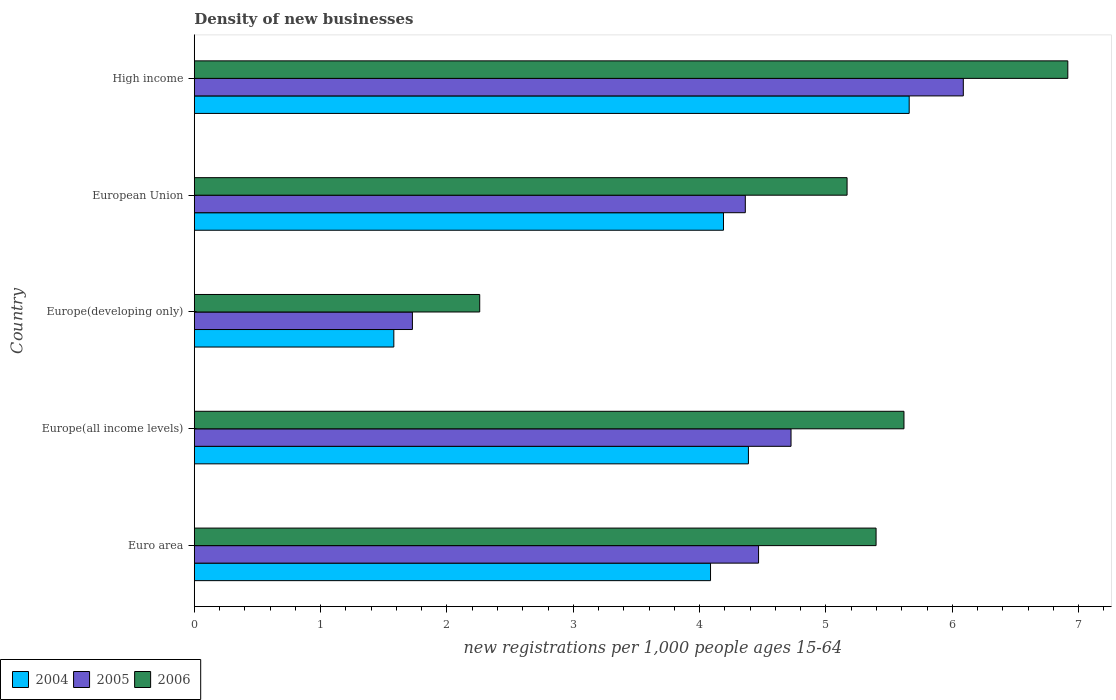How many different coloured bars are there?
Your response must be concise. 3. Are the number of bars per tick equal to the number of legend labels?
Give a very brief answer. Yes. Are the number of bars on each tick of the Y-axis equal?
Make the answer very short. Yes. How many bars are there on the 5th tick from the bottom?
Your response must be concise. 3. What is the label of the 5th group of bars from the top?
Your response must be concise. Euro area. What is the number of new registrations in 2004 in Europe(all income levels)?
Offer a terse response. 4.39. Across all countries, what is the maximum number of new registrations in 2005?
Give a very brief answer. 6.09. Across all countries, what is the minimum number of new registrations in 2004?
Make the answer very short. 1.58. In which country was the number of new registrations in 2005 minimum?
Your response must be concise. Europe(developing only). What is the total number of new registrations in 2004 in the graph?
Make the answer very short. 19.9. What is the difference between the number of new registrations in 2005 in European Union and that in High income?
Ensure brevity in your answer.  -1.73. What is the difference between the number of new registrations in 2004 in Euro area and the number of new registrations in 2006 in European Union?
Offer a very short reply. -1.08. What is the average number of new registrations in 2005 per country?
Offer a very short reply. 4.27. What is the difference between the number of new registrations in 2006 and number of new registrations in 2004 in High income?
Give a very brief answer. 1.26. In how many countries, is the number of new registrations in 2004 greater than 5.6 ?
Keep it short and to the point. 1. What is the ratio of the number of new registrations in 2004 in Euro area to that in Europe(developing only)?
Ensure brevity in your answer.  2.59. Is the number of new registrations in 2004 in Europe(all income levels) less than that in High income?
Offer a terse response. Yes. Is the difference between the number of new registrations in 2006 in Europe(developing only) and High income greater than the difference between the number of new registrations in 2004 in Europe(developing only) and High income?
Offer a terse response. No. What is the difference between the highest and the second highest number of new registrations in 2005?
Ensure brevity in your answer.  1.36. What is the difference between the highest and the lowest number of new registrations in 2005?
Provide a short and direct response. 4.36. What does the 3rd bar from the top in Euro area represents?
Offer a terse response. 2004. Is it the case that in every country, the sum of the number of new registrations in 2004 and number of new registrations in 2006 is greater than the number of new registrations in 2005?
Ensure brevity in your answer.  Yes. What is the difference between two consecutive major ticks on the X-axis?
Make the answer very short. 1. Where does the legend appear in the graph?
Give a very brief answer. Bottom left. What is the title of the graph?
Provide a succinct answer. Density of new businesses. Does "1962" appear as one of the legend labels in the graph?
Provide a short and direct response. No. What is the label or title of the X-axis?
Your answer should be compact. New registrations per 1,0 people ages 15-64. What is the new registrations per 1,000 people ages 15-64 in 2004 in Euro area?
Make the answer very short. 4.09. What is the new registrations per 1,000 people ages 15-64 of 2005 in Euro area?
Make the answer very short. 4.47. What is the new registrations per 1,000 people ages 15-64 of 2006 in Euro area?
Offer a very short reply. 5.4. What is the new registrations per 1,000 people ages 15-64 of 2004 in Europe(all income levels)?
Ensure brevity in your answer.  4.39. What is the new registrations per 1,000 people ages 15-64 in 2005 in Europe(all income levels)?
Give a very brief answer. 4.72. What is the new registrations per 1,000 people ages 15-64 of 2006 in Europe(all income levels)?
Your answer should be compact. 5.62. What is the new registrations per 1,000 people ages 15-64 in 2004 in Europe(developing only)?
Your response must be concise. 1.58. What is the new registrations per 1,000 people ages 15-64 of 2005 in Europe(developing only)?
Your response must be concise. 1.73. What is the new registrations per 1,000 people ages 15-64 in 2006 in Europe(developing only)?
Provide a succinct answer. 2.26. What is the new registrations per 1,000 people ages 15-64 of 2004 in European Union?
Your answer should be compact. 4.19. What is the new registrations per 1,000 people ages 15-64 of 2005 in European Union?
Provide a short and direct response. 4.36. What is the new registrations per 1,000 people ages 15-64 in 2006 in European Union?
Your answer should be compact. 5.17. What is the new registrations per 1,000 people ages 15-64 of 2004 in High income?
Make the answer very short. 5.66. What is the new registrations per 1,000 people ages 15-64 of 2005 in High income?
Your response must be concise. 6.09. What is the new registrations per 1,000 people ages 15-64 of 2006 in High income?
Your answer should be very brief. 6.91. Across all countries, what is the maximum new registrations per 1,000 people ages 15-64 of 2004?
Offer a very short reply. 5.66. Across all countries, what is the maximum new registrations per 1,000 people ages 15-64 in 2005?
Your answer should be very brief. 6.09. Across all countries, what is the maximum new registrations per 1,000 people ages 15-64 in 2006?
Give a very brief answer. 6.91. Across all countries, what is the minimum new registrations per 1,000 people ages 15-64 of 2004?
Make the answer very short. 1.58. Across all countries, what is the minimum new registrations per 1,000 people ages 15-64 in 2005?
Your answer should be compact. 1.73. Across all countries, what is the minimum new registrations per 1,000 people ages 15-64 of 2006?
Offer a terse response. 2.26. What is the total new registrations per 1,000 people ages 15-64 in 2004 in the graph?
Your response must be concise. 19.9. What is the total new registrations per 1,000 people ages 15-64 in 2005 in the graph?
Offer a very short reply. 21.37. What is the total new registrations per 1,000 people ages 15-64 in 2006 in the graph?
Ensure brevity in your answer.  25.36. What is the difference between the new registrations per 1,000 people ages 15-64 in 2004 in Euro area and that in Europe(all income levels)?
Offer a very short reply. -0.3. What is the difference between the new registrations per 1,000 people ages 15-64 in 2005 in Euro area and that in Europe(all income levels)?
Make the answer very short. -0.26. What is the difference between the new registrations per 1,000 people ages 15-64 in 2006 in Euro area and that in Europe(all income levels)?
Give a very brief answer. -0.22. What is the difference between the new registrations per 1,000 people ages 15-64 in 2004 in Euro area and that in Europe(developing only)?
Provide a short and direct response. 2.51. What is the difference between the new registrations per 1,000 people ages 15-64 in 2005 in Euro area and that in Europe(developing only)?
Your answer should be very brief. 2.74. What is the difference between the new registrations per 1,000 people ages 15-64 of 2006 in Euro area and that in Europe(developing only)?
Make the answer very short. 3.14. What is the difference between the new registrations per 1,000 people ages 15-64 of 2004 in Euro area and that in European Union?
Provide a succinct answer. -0.1. What is the difference between the new registrations per 1,000 people ages 15-64 of 2005 in Euro area and that in European Union?
Make the answer very short. 0.1. What is the difference between the new registrations per 1,000 people ages 15-64 of 2006 in Euro area and that in European Union?
Your answer should be compact. 0.23. What is the difference between the new registrations per 1,000 people ages 15-64 in 2004 in Euro area and that in High income?
Offer a very short reply. -1.57. What is the difference between the new registrations per 1,000 people ages 15-64 of 2005 in Euro area and that in High income?
Keep it short and to the point. -1.62. What is the difference between the new registrations per 1,000 people ages 15-64 in 2006 in Euro area and that in High income?
Provide a short and direct response. -1.52. What is the difference between the new registrations per 1,000 people ages 15-64 in 2004 in Europe(all income levels) and that in Europe(developing only)?
Give a very brief answer. 2.81. What is the difference between the new registrations per 1,000 people ages 15-64 of 2005 in Europe(all income levels) and that in Europe(developing only)?
Your answer should be compact. 3. What is the difference between the new registrations per 1,000 people ages 15-64 of 2006 in Europe(all income levels) and that in Europe(developing only)?
Give a very brief answer. 3.36. What is the difference between the new registrations per 1,000 people ages 15-64 of 2004 in Europe(all income levels) and that in European Union?
Your response must be concise. 0.2. What is the difference between the new registrations per 1,000 people ages 15-64 of 2005 in Europe(all income levels) and that in European Union?
Your answer should be compact. 0.36. What is the difference between the new registrations per 1,000 people ages 15-64 of 2006 in Europe(all income levels) and that in European Union?
Provide a short and direct response. 0.45. What is the difference between the new registrations per 1,000 people ages 15-64 in 2004 in Europe(all income levels) and that in High income?
Make the answer very short. -1.27. What is the difference between the new registrations per 1,000 people ages 15-64 of 2005 in Europe(all income levels) and that in High income?
Your answer should be compact. -1.36. What is the difference between the new registrations per 1,000 people ages 15-64 in 2006 in Europe(all income levels) and that in High income?
Make the answer very short. -1.3. What is the difference between the new registrations per 1,000 people ages 15-64 of 2004 in Europe(developing only) and that in European Union?
Keep it short and to the point. -2.61. What is the difference between the new registrations per 1,000 people ages 15-64 in 2005 in Europe(developing only) and that in European Union?
Ensure brevity in your answer.  -2.64. What is the difference between the new registrations per 1,000 people ages 15-64 in 2006 in Europe(developing only) and that in European Union?
Keep it short and to the point. -2.91. What is the difference between the new registrations per 1,000 people ages 15-64 of 2004 in Europe(developing only) and that in High income?
Provide a short and direct response. -4.08. What is the difference between the new registrations per 1,000 people ages 15-64 of 2005 in Europe(developing only) and that in High income?
Your answer should be compact. -4.36. What is the difference between the new registrations per 1,000 people ages 15-64 of 2006 in Europe(developing only) and that in High income?
Offer a very short reply. -4.66. What is the difference between the new registrations per 1,000 people ages 15-64 of 2004 in European Union and that in High income?
Make the answer very short. -1.47. What is the difference between the new registrations per 1,000 people ages 15-64 in 2005 in European Union and that in High income?
Ensure brevity in your answer.  -1.73. What is the difference between the new registrations per 1,000 people ages 15-64 of 2006 in European Union and that in High income?
Provide a succinct answer. -1.75. What is the difference between the new registrations per 1,000 people ages 15-64 in 2004 in Euro area and the new registrations per 1,000 people ages 15-64 in 2005 in Europe(all income levels)?
Make the answer very short. -0.64. What is the difference between the new registrations per 1,000 people ages 15-64 of 2004 in Euro area and the new registrations per 1,000 people ages 15-64 of 2006 in Europe(all income levels)?
Give a very brief answer. -1.53. What is the difference between the new registrations per 1,000 people ages 15-64 in 2005 in Euro area and the new registrations per 1,000 people ages 15-64 in 2006 in Europe(all income levels)?
Provide a short and direct response. -1.15. What is the difference between the new registrations per 1,000 people ages 15-64 in 2004 in Euro area and the new registrations per 1,000 people ages 15-64 in 2005 in Europe(developing only)?
Keep it short and to the point. 2.36. What is the difference between the new registrations per 1,000 people ages 15-64 in 2004 in Euro area and the new registrations per 1,000 people ages 15-64 in 2006 in Europe(developing only)?
Keep it short and to the point. 1.83. What is the difference between the new registrations per 1,000 people ages 15-64 in 2005 in Euro area and the new registrations per 1,000 people ages 15-64 in 2006 in Europe(developing only)?
Keep it short and to the point. 2.21. What is the difference between the new registrations per 1,000 people ages 15-64 of 2004 in Euro area and the new registrations per 1,000 people ages 15-64 of 2005 in European Union?
Make the answer very short. -0.28. What is the difference between the new registrations per 1,000 people ages 15-64 in 2004 in Euro area and the new registrations per 1,000 people ages 15-64 in 2006 in European Union?
Your answer should be very brief. -1.08. What is the difference between the new registrations per 1,000 people ages 15-64 of 2005 in Euro area and the new registrations per 1,000 people ages 15-64 of 2006 in European Union?
Your answer should be very brief. -0.7. What is the difference between the new registrations per 1,000 people ages 15-64 of 2004 in Euro area and the new registrations per 1,000 people ages 15-64 of 2005 in High income?
Your answer should be compact. -2. What is the difference between the new registrations per 1,000 people ages 15-64 of 2004 in Euro area and the new registrations per 1,000 people ages 15-64 of 2006 in High income?
Offer a terse response. -2.83. What is the difference between the new registrations per 1,000 people ages 15-64 in 2005 in Euro area and the new registrations per 1,000 people ages 15-64 in 2006 in High income?
Offer a terse response. -2.45. What is the difference between the new registrations per 1,000 people ages 15-64 of 2004 in Europe(all income levels) and the new registrations per 1,000 people ages 15-64 of 2005 in Europe(developing only)?
Your answer should be very brief. 2.66. What is the difference between the new registrations per 1,000 people ages 15-64 of 2004 in Europe(all income levels) and the new registrations per 1,000 people ages 15-64 of 2006 in Europe(developing only)?
Give a very brief answer. 2.13. What is the difference between the new registrations per 1,000 people ages 15-64 of 2005 in Europe(all income levels) and the new registrations per 1,000 people ages 15-64 of 2006 in Europe(developing only)?
Provide a short and direct response. 2.46. What is the difference between the new registrations per 1,000 people ages 15-64 in 2004 in Europe(all income levels) and the new registrations per 1,000 people ages 15-64 in 2005 in European Union?
Provide a short and direct response. 0.02. What is the difference between the new registrations per 1,000 people ages 15-64 of 2004 in Europe(all income levels) and the new registrations per 1,000 people ages 15-64 of 2006 in European Union?
Your answer should be compact. -0.78. What is the difference between the new registrations per 1,000 people ages 15-64 in 2005 in Europe(all income levels) and the new registrations per 1,000 people ages 15-64 in 2006 in European Union?
Your answer should be compact. -0.44. What is the difference between the new registrations per 1,000 people ages 15-64 in 2004 in Europe(all income levels) and the new registrations per 1,000 people ages 15-64 in 2005 in High income?
Provide a succinct answer. -1.7. What is the difference between the new registrations per 1,000 people ages 15-64 in 2004 in Europe(all income levels) and the new registrations per 1,000 people ages 15-64 in 2006 in High income?
Your answer should be very brief. -2.53. What is the difference between the new registrations per 1,000 people ages 15-64 of 2005 in Europe(all income levels) and the new registrations per 1,000 people ages 15-64 of 2006 in High income?
Offer a very short reply. -2.19. What is the difference between the new registrations per 1,000 people ages 15-64 of 2004 in Europe(developing only) and the new registrations per 1,000 people ages 15-64 of 2005 in European Union?
Provide a succinct answer. -2.78. What is the difference between the new registrations per 1,000 people ages 15-64 of 2004 in Europe(developing only) and the new registrations per 1,000 people ages 15-64 of 2006 in European Union?
Provide a succinct answer. -3.59. What is the difference between the new registrations per 1,000 people ages 15-64 of 2005 in Europe(developing only) and the new registrations per 1,000 people ages 15-64 of 2006 in European Union?
Ensure brevity in your answer.  -3.44. What is the difference between the new registrations per 1,000 people ages 15-64 of 2004 in Europe(developing only) and the new registrations per 1,000 people ages 15-64 of 2005 in High income?
Offer a very short reply. -4.51. What is the difference between the new registrations per 1,000 people ages 15-64 in 2004 in Europe(developing only) and the new registrations per 1,000 people ages 15-64 in 2006 in High income?
Offer a very short reply. -5.33. What is the difference between the new registrations per 1,000 people ages 15-64 in 2005 in Europe(developing only) and the new registrations per 1,000 people ages 15-64 in 2006 in High income?
Your response must be concise. -5.19. What is the difference between the new registrations per 1,000 people ages 15-64 of 2004 in European Union and the new registrations per 1,000 people ages 15-64 of 2005 in High income?
Provide a short and direct response. -1.9. What is the difference between the new registrations per 1,000 people ages 15-64 of 2004 in European Union and the new registrations per 1,000 people ages 15-64 of 2006 in High income?
Ensure brevity in your answer.  -2.73. What is the difference between the new registrations per 1,000 people ages 15-64 of 2005 in European Union and the new registrations per 1,000 people ages 15-64 of 2006 in High income?
Give a very brief answer. -2.55. What is the average new registrations per 1,000 people ages 15-64 in 2004 per country?
Provide a succinct answer. 3.98. What is the average new registrations per 1,000 people ages 15-64 in 2005 per country?
Provide a short and direct response. 4.27. What is the average new registrations per 1,000 people ages 15-64 in 2006 per country?
Provide a short and direct response. 5.07. What is the difference between the new registrations per 1,000 people ages 15-64 in 2004 and new registrations per 1,000 people ages 15-64 in 2005 in Euro area?
Your answer should be compact. -0.38. What is the difference between the new registrations per 1,000 people ages 15-64 of 2004 and new registrations per 1,000 people ages 15-64 of 2006 in Euro area?
Your answer should be compact. -1.31. What is the difference between the new registrations per 1,000 people ages 15-64 in 2005 and new registrations per 1,000 people ages 15-64 in 2006 in Euro area?
Give a very brief answer. -0.93. What is the difference between the new registrations per 1,000 people ages 15-64 of 2004 and new registrations per 1,000 people ages 15-64 of 2005 in Europe(all income levels)?
Offer a terse response. -0.34. What is the difference between the new registrations per 1,000 people ages 15-64 of 2004 and new registrations per 1,000 people ages 15-64 of 2006 in Europe(all income levels)?
Keep it short and to the point. -1.23. What is the difference between the new registrations per 1,000 people ages 15-64 in 2005 and new registrations per 1,000 people ages 15-64 in 2006 in Europe(all income levels)?
Keep it short and to the point. -0.89. What is the difference between the new registrations per 1,000 people ages 15-64 in 2004 and new registrations per 1,000 people ages 15-64 in 2005 in Europe(developing only)?
Provide a succinct answer. -0.15. What is the difference between the new registrations per 1,000 people ages 15-64 of 2004 and new registrations per 1,000 people ages 15-64 of 2006 in Europe(developing only)?
Provide a short and direct response. -0.68. What is the difference between the new registrations per 1,000 people ages 15-64 in 2005 and new registrations per 1,000 people ages 15-64 in 2006 in Europe(developing only)?
Provide a short and direct response. -0.53. What is the difference between the new registrations per 1,000 people ages 15-64 of 2004 and new registrations per 1,000 people ages 15-64 of 2005 in European Union?
Ensure brevity in your answer.  -0.17. What is the difference between the new registrations per 1,000 people ages 15-64 in 2004 and new registrations per 1,000 people ages 15-64 in 2006 in European Union?
Your answer should be very brief. -0.98. What is the difference between the new registrations per 1,000 people ages 15-64 of 2005 and new registrations per 1,000 people ages 15-64 of 2006 in European Union?
Offer a very short reply. -0.81. What is the difference between the new registrations per 1,000 people ages 15-64 of 2004 and new registrations per 1,000 people ages 15-64 of 2005 in High income?
Offer a terse response. -0.43. What is the difference between the new registrations per 1,000 people ages 15-64 of 2004 and new registrations per 1,000 people ages 15-64 of 2006 in High income?
Provide a short and direct response. -1.26. What is the difference between the new registrations per 1,000 people ages 15-64 in 2005 and new registrations per 1,000 people ages 15-64 in 2006 in High income?
Ensure brevity in your answer.  -0.83. What is the ratio of the new registrations per 1,000 people ages 15-64 of 2004 in Euro area to that in Europe(all income levels)?
Your response must be concise. 0.93. What is the ratio of the new registrations per 1,000 people ages 15-64 in 2005 in Euro area to that in Europe(all income levels)?
Your answer should be very brief. 0.95. What is the ratio of the new registrations per 1,000 people ages 15-64 in 2006 in Euro area to that in Europe(all income levels)?
Offer a very short reply. 0.96. What is the ratio of the new registrations per 1,000 people ages 15-64 in 2004 in Euro area to that in Europe(developing only)?
Your response must be concise. 2.59. What is the ratio of the new registrations per 1,000 people ages 15-64 in 2005 in Euro area to that in Europe(developing only)?
Keep it short and to the point. 2.59. What is the ratio of the new registrations per 1,000 people ages 15-64 of 2006 in Euro area to that in Europe(developing only)?
Make the answer very short. 2.39. What is the ratio of the new registrations per 1,000 people ages 15-64 of 2004 in Euro area to that in European Union?
Your response must be concise. 0.98. What is the ratio of the new registrations per 1,000 people ages 15-64 in 2005 in Euro area to that in European Union?
Your response must be concise. 1.02. What is the ratio of the new registrations per 1,000 people ages 15-64 of 2006 in Euro area to that in European Union?
Offer a terse response. 1.04. What is the ratio of the new registrations per 1,000 people ages 15-64 of 2004 in Euro area to that in High income?
Provide a succinct answer. 0.72. What is the ratio of the new registrations per 1,000 people ages 15-64 in 2005 in Euro area to that in High income?
Offer a very short reply. 0.73. What is the ratio of the new registrations per 1,000 people ages 15-64 of 2006 in Euro area to that in High income?
Keep it short and to the point. 0.78. What is the ratio of the new registrations per 1,000 people ages 15-64 in 2004 in Europe(all income levels) to that in Europe(developing only)?
Give a very brief answer. 2.78. What is the ratio of the new registrations per 1,000 people ages 15-64 in 2005 in Europe(all income levels) to that in Europe(developing only)?
Provide a short and direct response. 2.74. What is the ratio of the new registrations per 1,000 people ages 15-64 in 2006 in Europe(all income levels) to that in Europe(developing only)?
Provide a succinct answer. 2.49. What is the ratio of the new registrations per 1,000 people ages 15-64 of 2004 in Europe(all income levels) to that in European Union?
Offer a very short reply. 1.05. What is the ratio of the new registrations per 1,000 people ages 15-64 in 2005 in Europe(all income levels) to that in European Union?
Ensure brevity in your answer.  1.08. What is the ratio of the new registrations per 1,000 people ages 15-64 in 2006 in Europe(all income levels) to that in European Union?
Your answer should be very brief. 1.09. What is the ratio of the new registrations per 1,000 people ages 15-64 of 2004 in Europe(all income levels) to that in High income?
Offer a very short reply. 0.78. What is the ratio of the new registrations per 1,000 people ages 15-64 of 2005 in Europe(all income levels) to that in High income?
Provide a short and direct response. 0.78. What is the ratio of the new registrations per 1,000 people ages 15-64 in 2006 in Europe(all income levels) to that in High income?
Keep it short and to the point. 0.81. What is the ratio of the new registrations per 1,000 people ages 15-64 in 2004 in Europe(developing only) to that in European Union?
Provide a succinct answer. 0.38. What is the ratio of the new registrations per 1,000 people ages 15-64 of 2005 in Europe(developing only) to that in European Union?
Give a very brief answer. 0.4. What is the ratio of the new registrations per 1,000 people ages 15-64 of 2006 in Europe(developing only) to that in European Union?
Keep it short and to the point. 0.44. What is the ratio of the new registrations per 1,000 people ages 15-64 in 2004 in Europe(developing only) to that in High income?
Give a very brief answer. 0.28. What is the ratio of the new registrations per 1,000 people ages 15-64 in 2005 in Europe(developing only) to that in High income?
Make the answer very short. 0.28. What is the ratio of the new registrations per 1,000 people ages 15-64 in 2006 in Europe(developing only) to that in High income?
Make the answer very short. 0.33. What is the ratio of the new registrations per 1,000 people ages 15-64 of 2004 in European Union to that in High income?
Offer a very short reply. 0.74. What is the ratio of the new registrations per 1,000 people ages 15-64 of 2005 in European Union to that in High income?
Keep it short and to the point. 0.72. What is the ratio of the new registrations per 1,000 people ages 15-64 in 2006 in European Union to that in High income?
Give a very brief answer. 0.75. What is the difference between the highest and the second highest new registrations per 1,000 people ages 15-64 of 2004?
Keep it short and to the point. 1.27. What is the difference between the highest and the second highest new registrations per 1,000 people ages 15-64 in 2005?
Give a very brief answer. 1.36. What is the difference between the highest and the second highest new registrations per 1,000 people ages 15-64 of 2006?
Give a very brief answer. 1.3. What is the difference between the highest and the lowest new registrations per 1,000 people ages 15-64 of 2004?
Make the answer very short. 4.08. What is the difference between the highest and the lowest new registrations per 1,000 people ages 15-64 of 2005?
Make the answer very short. 4.36. What is the difference between the highest and the lowest new registrations per 1,000 people ages 15-64 of 2006?
Offer a terse response. 4.66. 